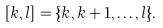<formula> <loc_0><loc_0><loc_500><loc_500>[ k , l ] = \{ k , k + 1 , \dots , l \} .</formula> 